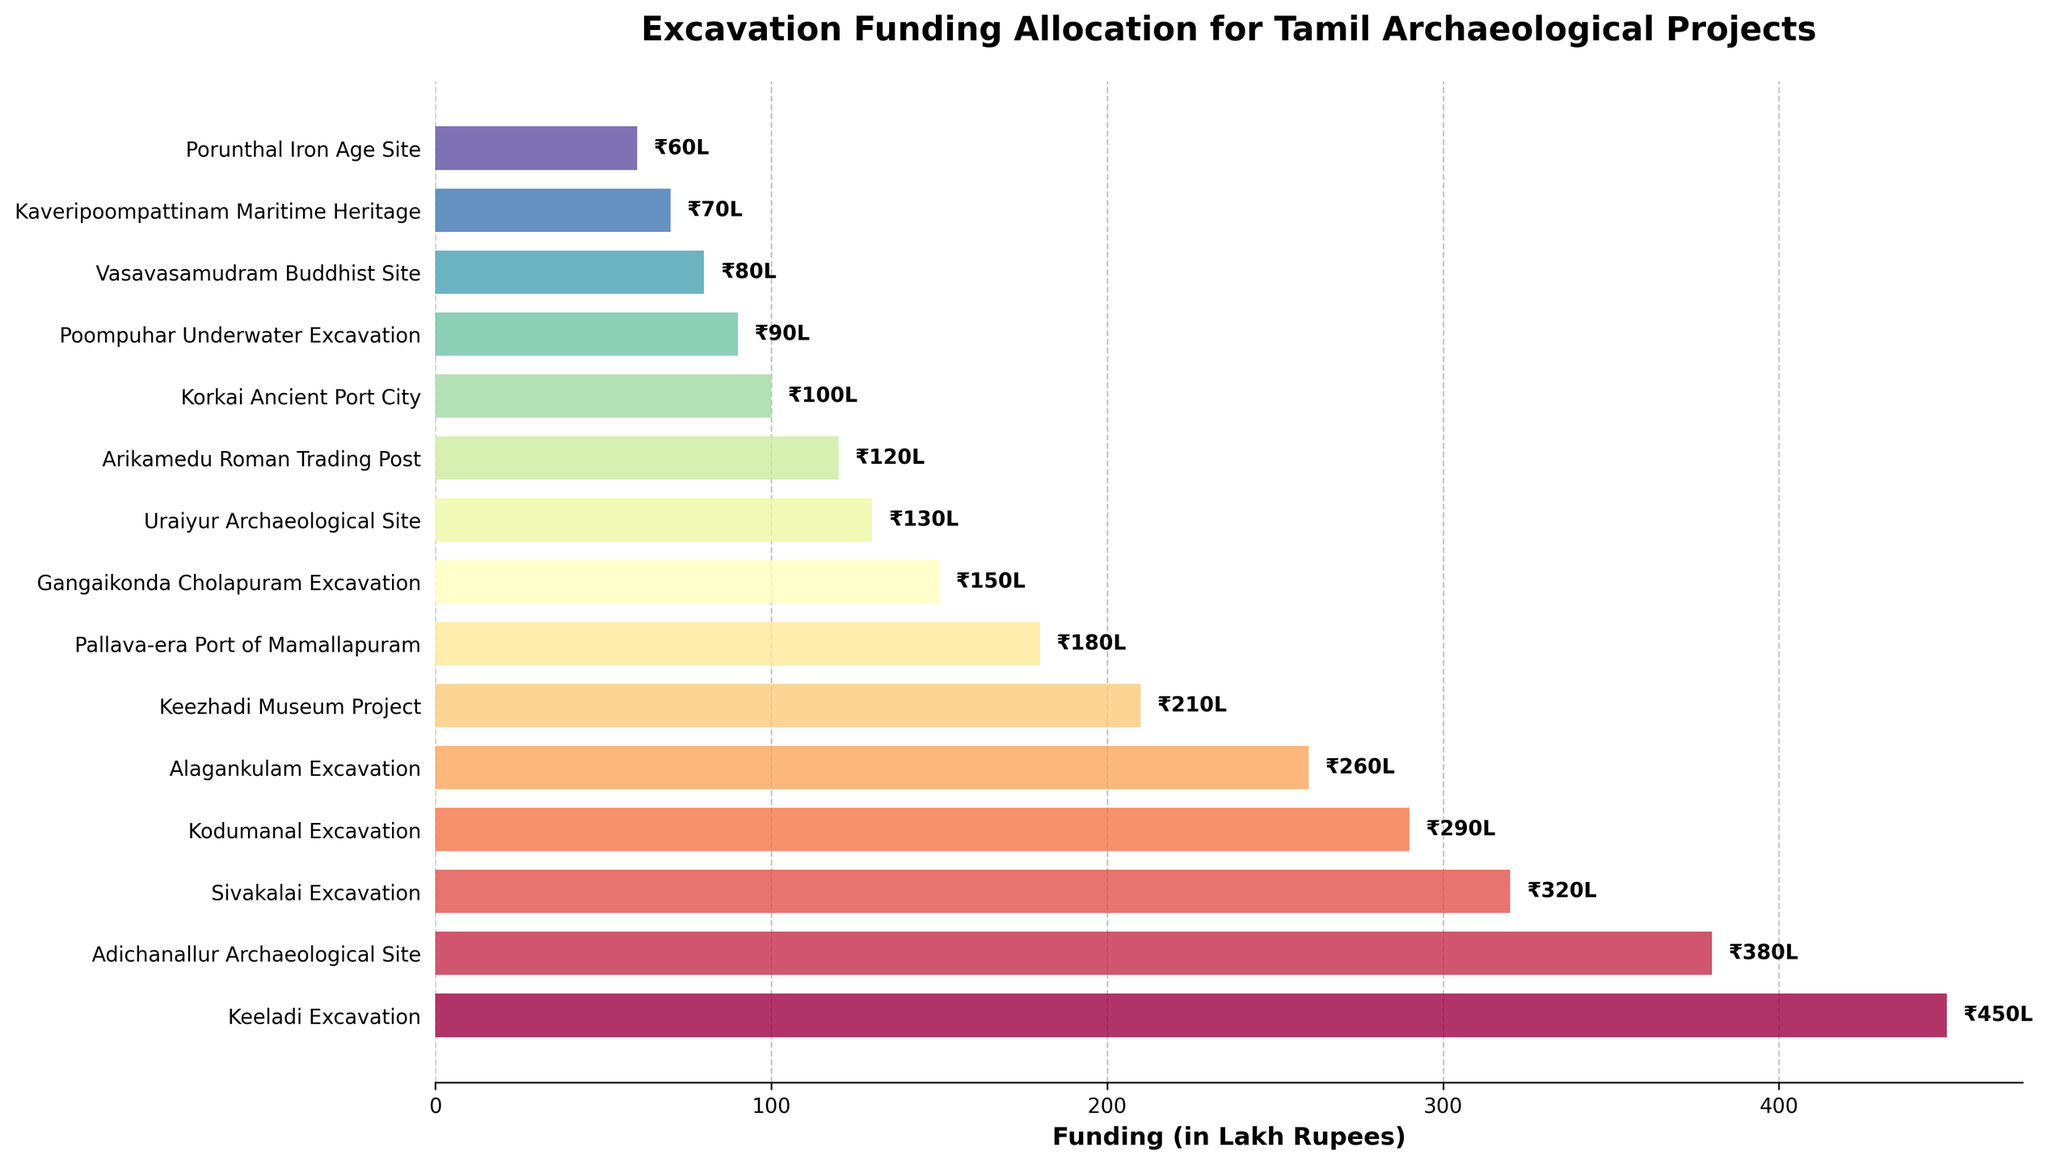Which project received the most funding? The project with the longest bar on the chart received the most funding, which is listed on the top position due to the horizontal bar chart sorting. The longest bar corresponds to the "Keeladi Excavation" project.
Answer: Keeladi Excavation What is the combined funding for the Adichanallur and Sivakalai Excavation projects? To find the combined funding, add the funding amounts for Adichanallur Archaeological Site and Sivakalai Excavation. The amounts are 380 Lakh Rupees and 320 Lakh Rupees respectively. So, 380 + 320 = 700.
Answer: 700 Lakh Rupees How does the funding for the Kodumanal Excavation compare to the Alagankulam Excavation? Compare the lengths of the bars for Kodumanal Excavation and Alagankulam Excavation. Kodumanal Excavation received 290 Lakh Rupees, and Alagankulam Excavation received 260 Lakh Rupees. Kodumanal received more funding.
Answer: Kodumanal Excavation received more What is the average funding allocated to the top three funded projects? The top three funded projects are Keeladi Excavation (450 Lakh Rupees), Adichanallur Archaeological Site (380 Lakh Rupees), and Sivakalai Excavation (320 Lakh Rupees). The sum of their funding is 450 + 380 + 320 = 1150 Lakh Rupees. The average is 1150 / 3 = 383.33.
Answer: 383.33 Lakh Rupees How much more funding did the Keeladi Excavation receive than the Gangaikonda Cholapuram Excavation? Subtract the funding amount of Gangaikonda Cholapuram Excavation from Keeladi Excavation. Keeladi received 450 Lakh Rupees, and Gangaikonda Cholapuram received 150 Lakh Rupees. 450 - 150 = 300.
Answer: 300 Lakh Rupees Which projects received less than 100 Lakh Rupees in funding? Look at the bars on the chart that are shorter and end before the 100 Lakh Rupees mark on the x-axis. The projects that received less than 100 Lakh Rupees are Poompuhar Underwater Excavation (90), Vasavasamudram Buddhist Site (80), Kaveripoompattinam Maritime Heritage (70), and Porunthal Iron Age Site (60).
Answer: Poompuhar Underwater Excavation, Vasavasamudram Buddhist Site, Kaveripoompattinam Maritime Heritage, Porunthal Iron Age Site What proportion of the total funding was allocated to the Keeladi Excavation project? Calculate the proportion by dividing Keeladi Excavation's funding by the total funding and then multiplying by 100 to get the percentage. The total funding is the sum of all the listed funding amounts. Total funding = 450 + 380 + 320 + 290 + 260 + 210 + 180 + 150 + 130 + 120 + 100 + 90 + 80 + 70 + 60 = 2890 Lakh Rupees. Proportion = (450 / 2890) * 100 ≈ 15.57%.
Answer: 15.57% Between the Keezhadi Museum Project and the Pallava-era Port of Mamallapuram, which received less funding and by how much? Compare the bars for Keezhadi Museum Project and Pallava-era Port of Mamallapuram. Keezhadi Museum Project received 210 Lakh Rupees, and Pallava-era Port of Mamallapuram received 180 Lakh Rupees. Calculate the difference: 210 - 180 = 30. The Pallava-era Port of Mamallapuram received less by 30 Lakh Rupees.
Answer: Pallava-era Port of Mamallapuram, 30 Lakh Rupees less 